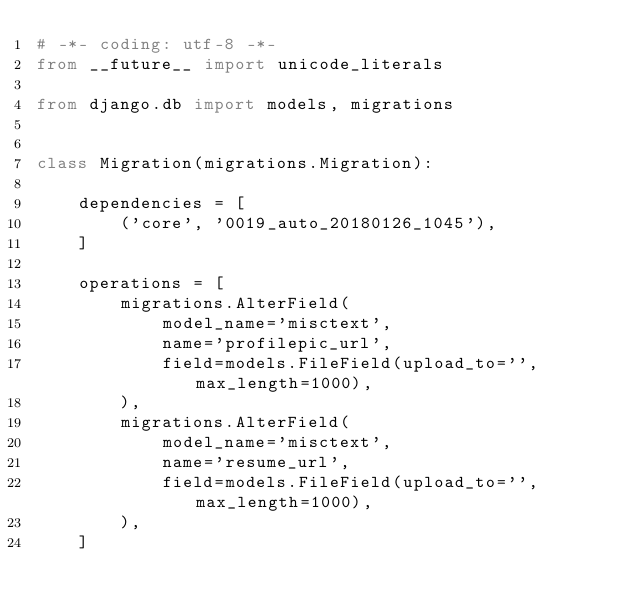<code> <loc_0><loc_0><loc_500><loc_500><_Python_># -*- coding: utf-8 -*-
from __future__ import unicode_literals

from django.db import models, migrations


class Migration(migrations.Migration):

    dependencies = [
        ('core', '0019_auto_20180126_1045'),
    ]

    operations = [
        migrations.AlterField(
            model_name='misctext',
            name='profilepic_url',
            field=models.FileField(upload_to='', max_length=1000),
        ),
        migrations.AlterField(
            model_name='misctext',
            name='resume_url',
            field=models.FileField(upload_to='', max_length=1000),
        ),
    ]
</code> 